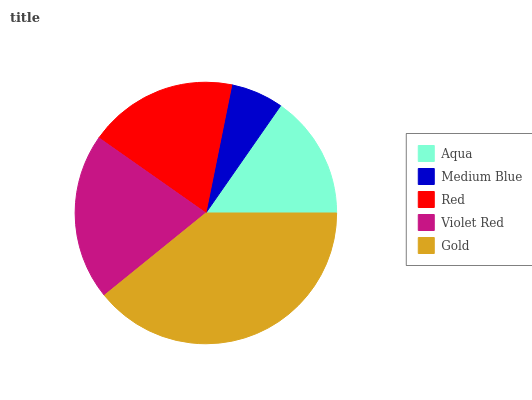Is Medium Blue the minimum?
Answer yes or no. Yes. Is Gold the maximum?
Answer yes or no. Yes. Is Red the minimum?
Answer yes or no. No. Is Red the maximum?
Answer yes or no. No. Is Red greater than Medium Blue?
Answer yes or no. Yes. Is Medium Blue less than Red?
Answer yes or no. Yes. Is Medium Blue greater than Red?
Answer yes or no. No. Is Red less than Medium Blue?
Answer yes or no. No. Is Red the high median?
Answer yes or no. Yes. Is Red the low median?
Answer yes or no. Yes. Is Violet Red the high median?
Answer yes or no. No. Is Aqua the low median?
Answer yes or no. No. 